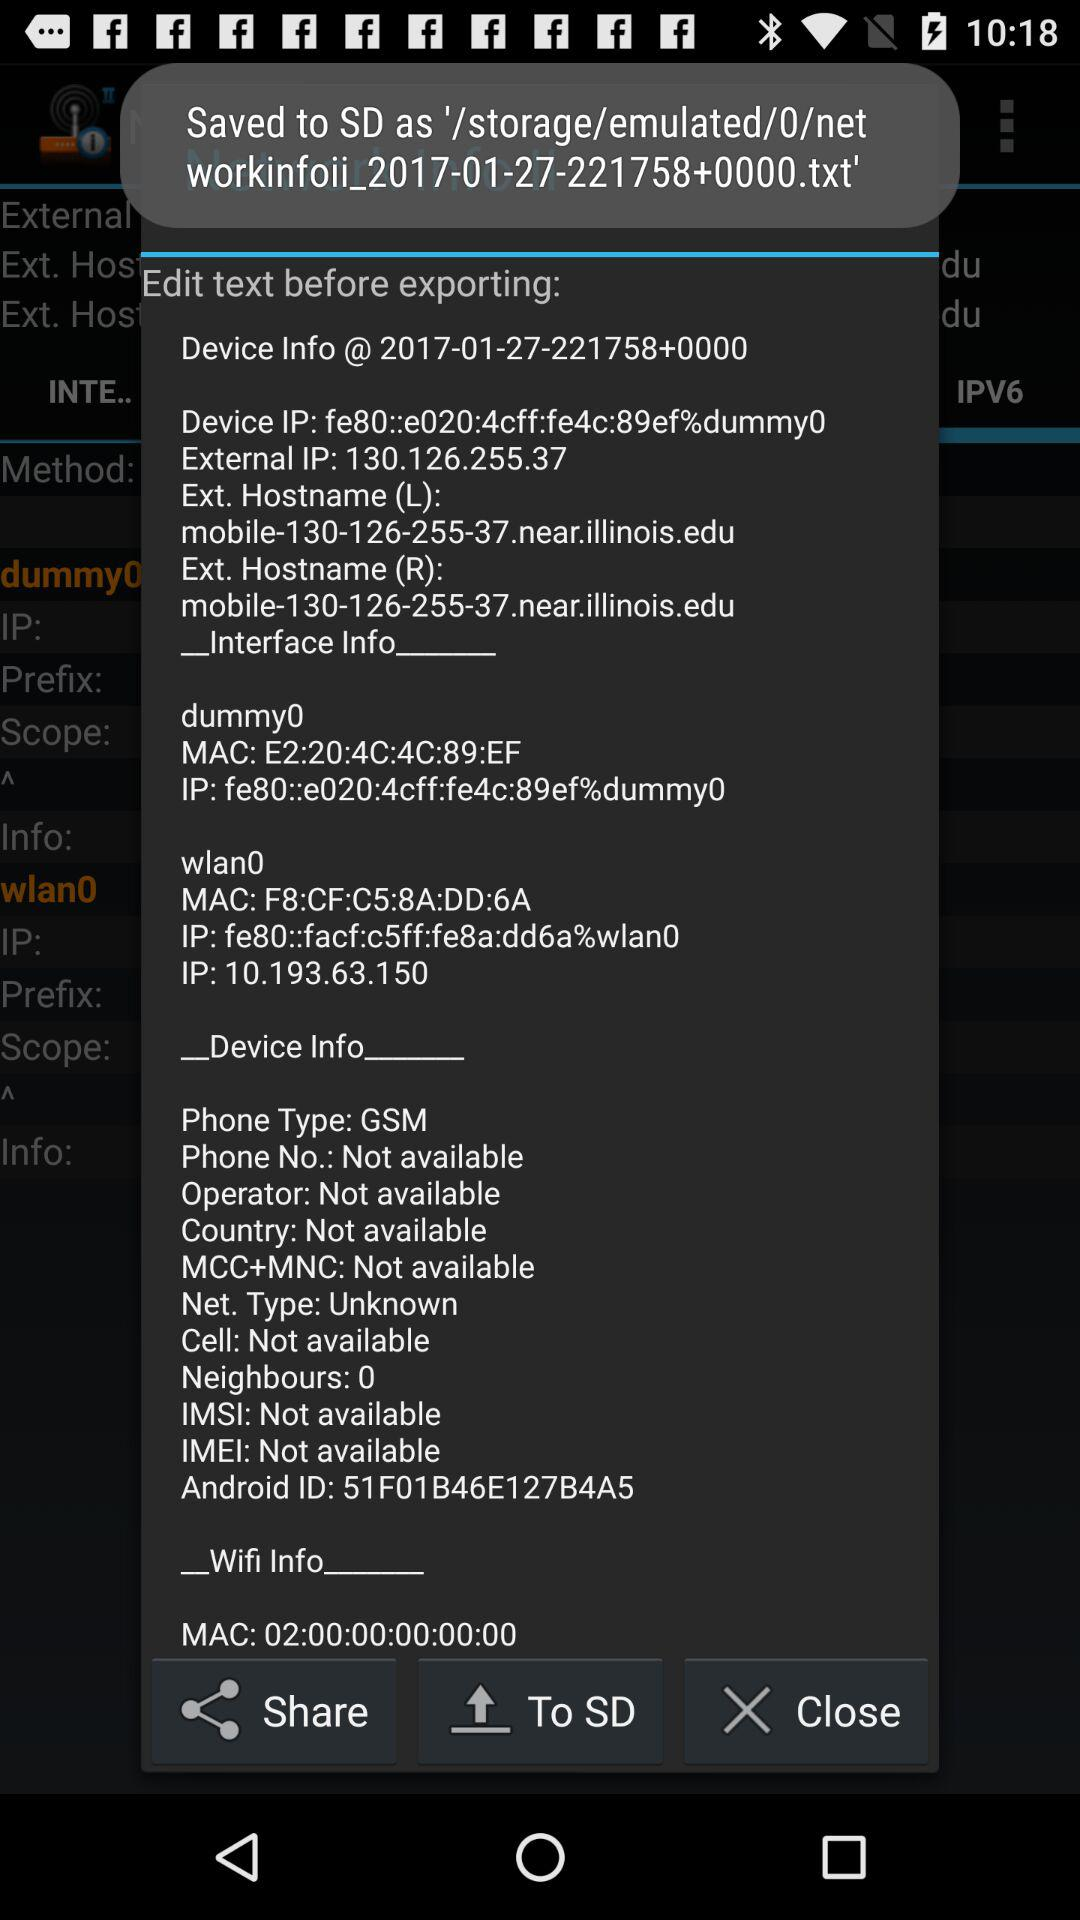What is the device's IP address? The IP address is "fe80::e020:4cff:fe4c:89ef%dummy0". 